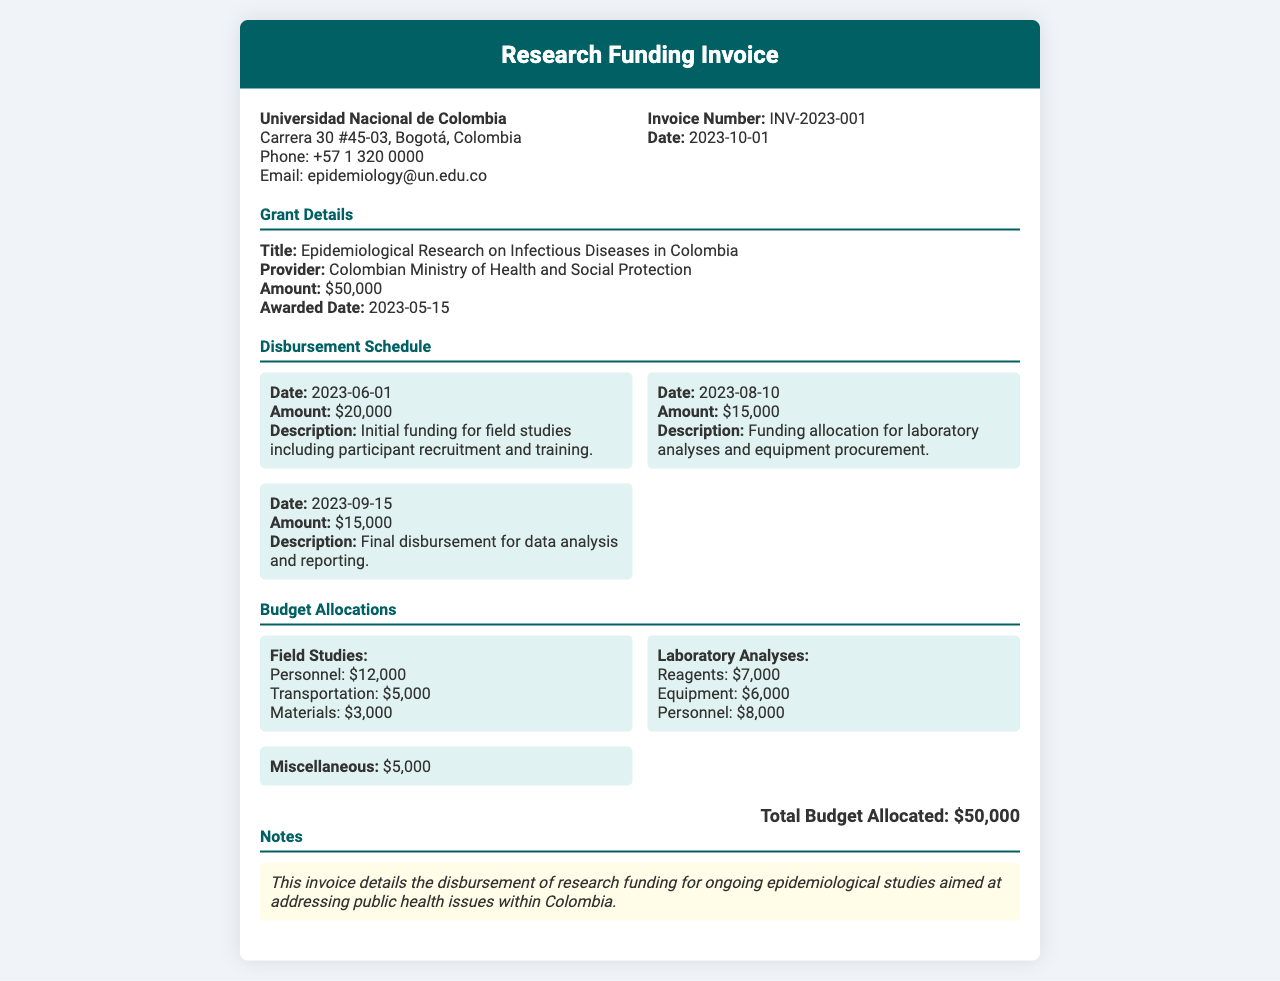What is the invoice number? The invoice number is explicitly mentioned in the document, which is INV-2023-001.
Answer: INV-2023-001 What is the total budget allocated? The total budget allocated is stated in the document as $50,000.
Answer: $50,000 When was the initial funding disbursement made? The date of the initial funding disbursement is specifically listed as 2023-06-01.
Answer: 2023-06-01 How much was allocated for laboratory analyses? The budget allocations include specific amounts for laboratory analyses, which total to $21,000.
Answer: $21,000 Who is the provider of the grant? The document mentions the provider of the grant as the Colombian Ministry of Health and Social Protection.
Answer: Colombian Ministry of Health and Social Protection What was the awarded date for the grant? The awarded date for the grant is found in the document as 2023-05-15.
Answer: 2023-05-15 What is the purpose of the allocated miscellaneous budget? The miscellaneous budget is stated to cover unallocated or extra expenses related to the research funding.
Answer: $5,000 How much was disbursed on 2023-08-10? The amount disbursed on that date is noted as $15,000 for laboratory analyses and equipment procurement.
Answer: $15,000 What type of studies is the funding for? The funding is explicitly stated to be for epidemiological research on infectious diseases.
Answer: Epidemiological Research on Infectious Diseases in Colombia 